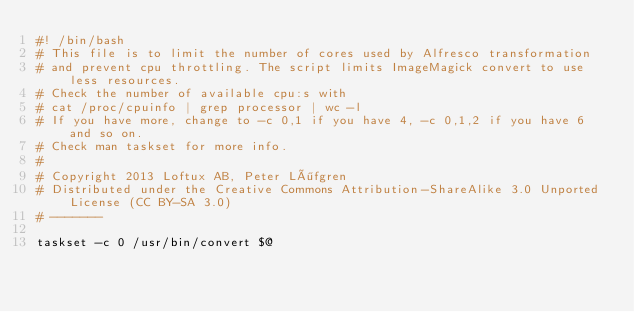<code> <loc_0><loc_0><loc_500><loc_500><_Bash_>#! /bin/bash
# This file is to limit the number of cores used by Alfresco transformation
# and prevent cpu throttling. The script limits ImageMagick convert to use less resources.
# Check the number of available cpu:s with
# cat /proc/cpuinfo | grep processor | wc -l
# If you have more, change to -c 0,1 if you have 4, -c 0,1,2 if you have 6 and so on.
# Check man taskset for more info.
# 
# Copyright 2013 Loftux AB, Peter Löfgren
# Distributed under the Creative Commons Attribution-ShareAlike 3.0 Unported License (CC BY-SA 3.0)
# -------

taskset -c 0 /usr/bin/convert $@
</code> 